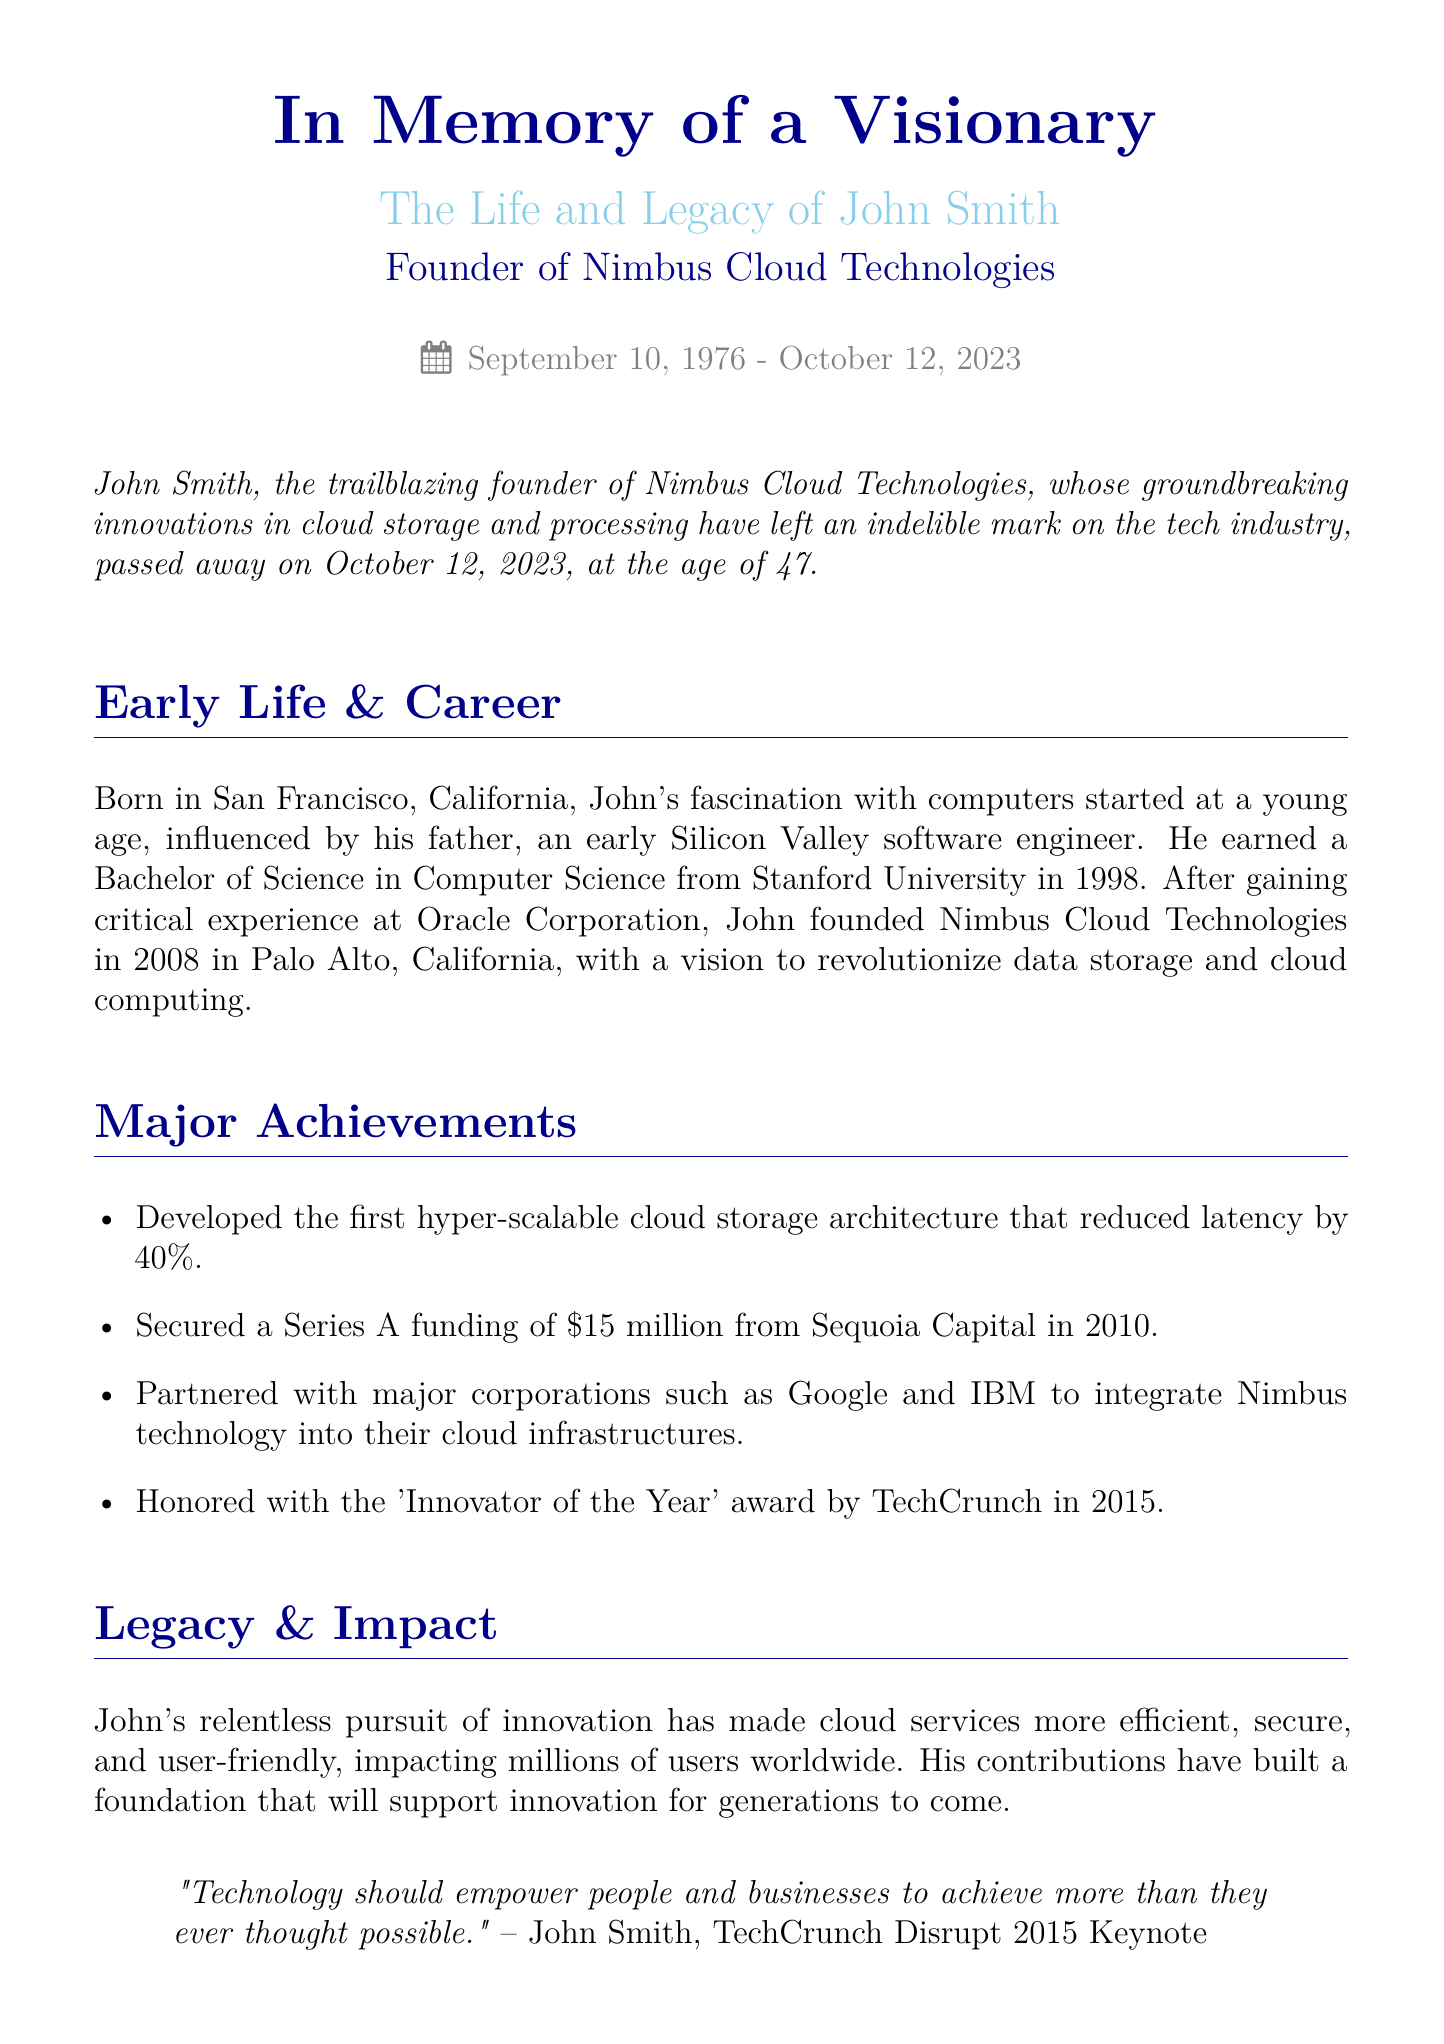What is the full name of the founder? The document states that the founder's full name is John Smith.
Answer: John Smith When was Nimbus Cloud Technologies founded? The document mentions that Nimbus Cloud Technologies was founded in 2008.
Answer: 2008 How old was John Smith when he passed away? The document states that John Smith passed away at the age of 47.
Answer: 47 What major award did John receive in 2015? According to the document, John was honored with the 'Innovator of the Year' award by TechCrunch.
Answer: Innovator of the Year Which two corporations did Nimbus partner with? The document lists Google and IBM as the corporations Nimbus partnered with.
Answer: Google and IBM What did John Smith aim to revolutionize? The document indicates that John aimed to revolutionize data storage and cloud computing.
Answer: data storage and cloud computing What is the name of the foundation John established? The document states that John established the Nimbus Foundation in 2016.
Answer: Nimbus Foundation What was John’s quote about technology? The document includes a quote from John stating, "Technology should empower people and businesses to achieve more than they ever thought possible."
Answer: "Technology should empower people and businesses to achieve more than they ever thought possible." What was John Smith’s profession? The document describes John as a trailblazing founder in the tech industry, specifically in cloud technologies.
Answer: founder 